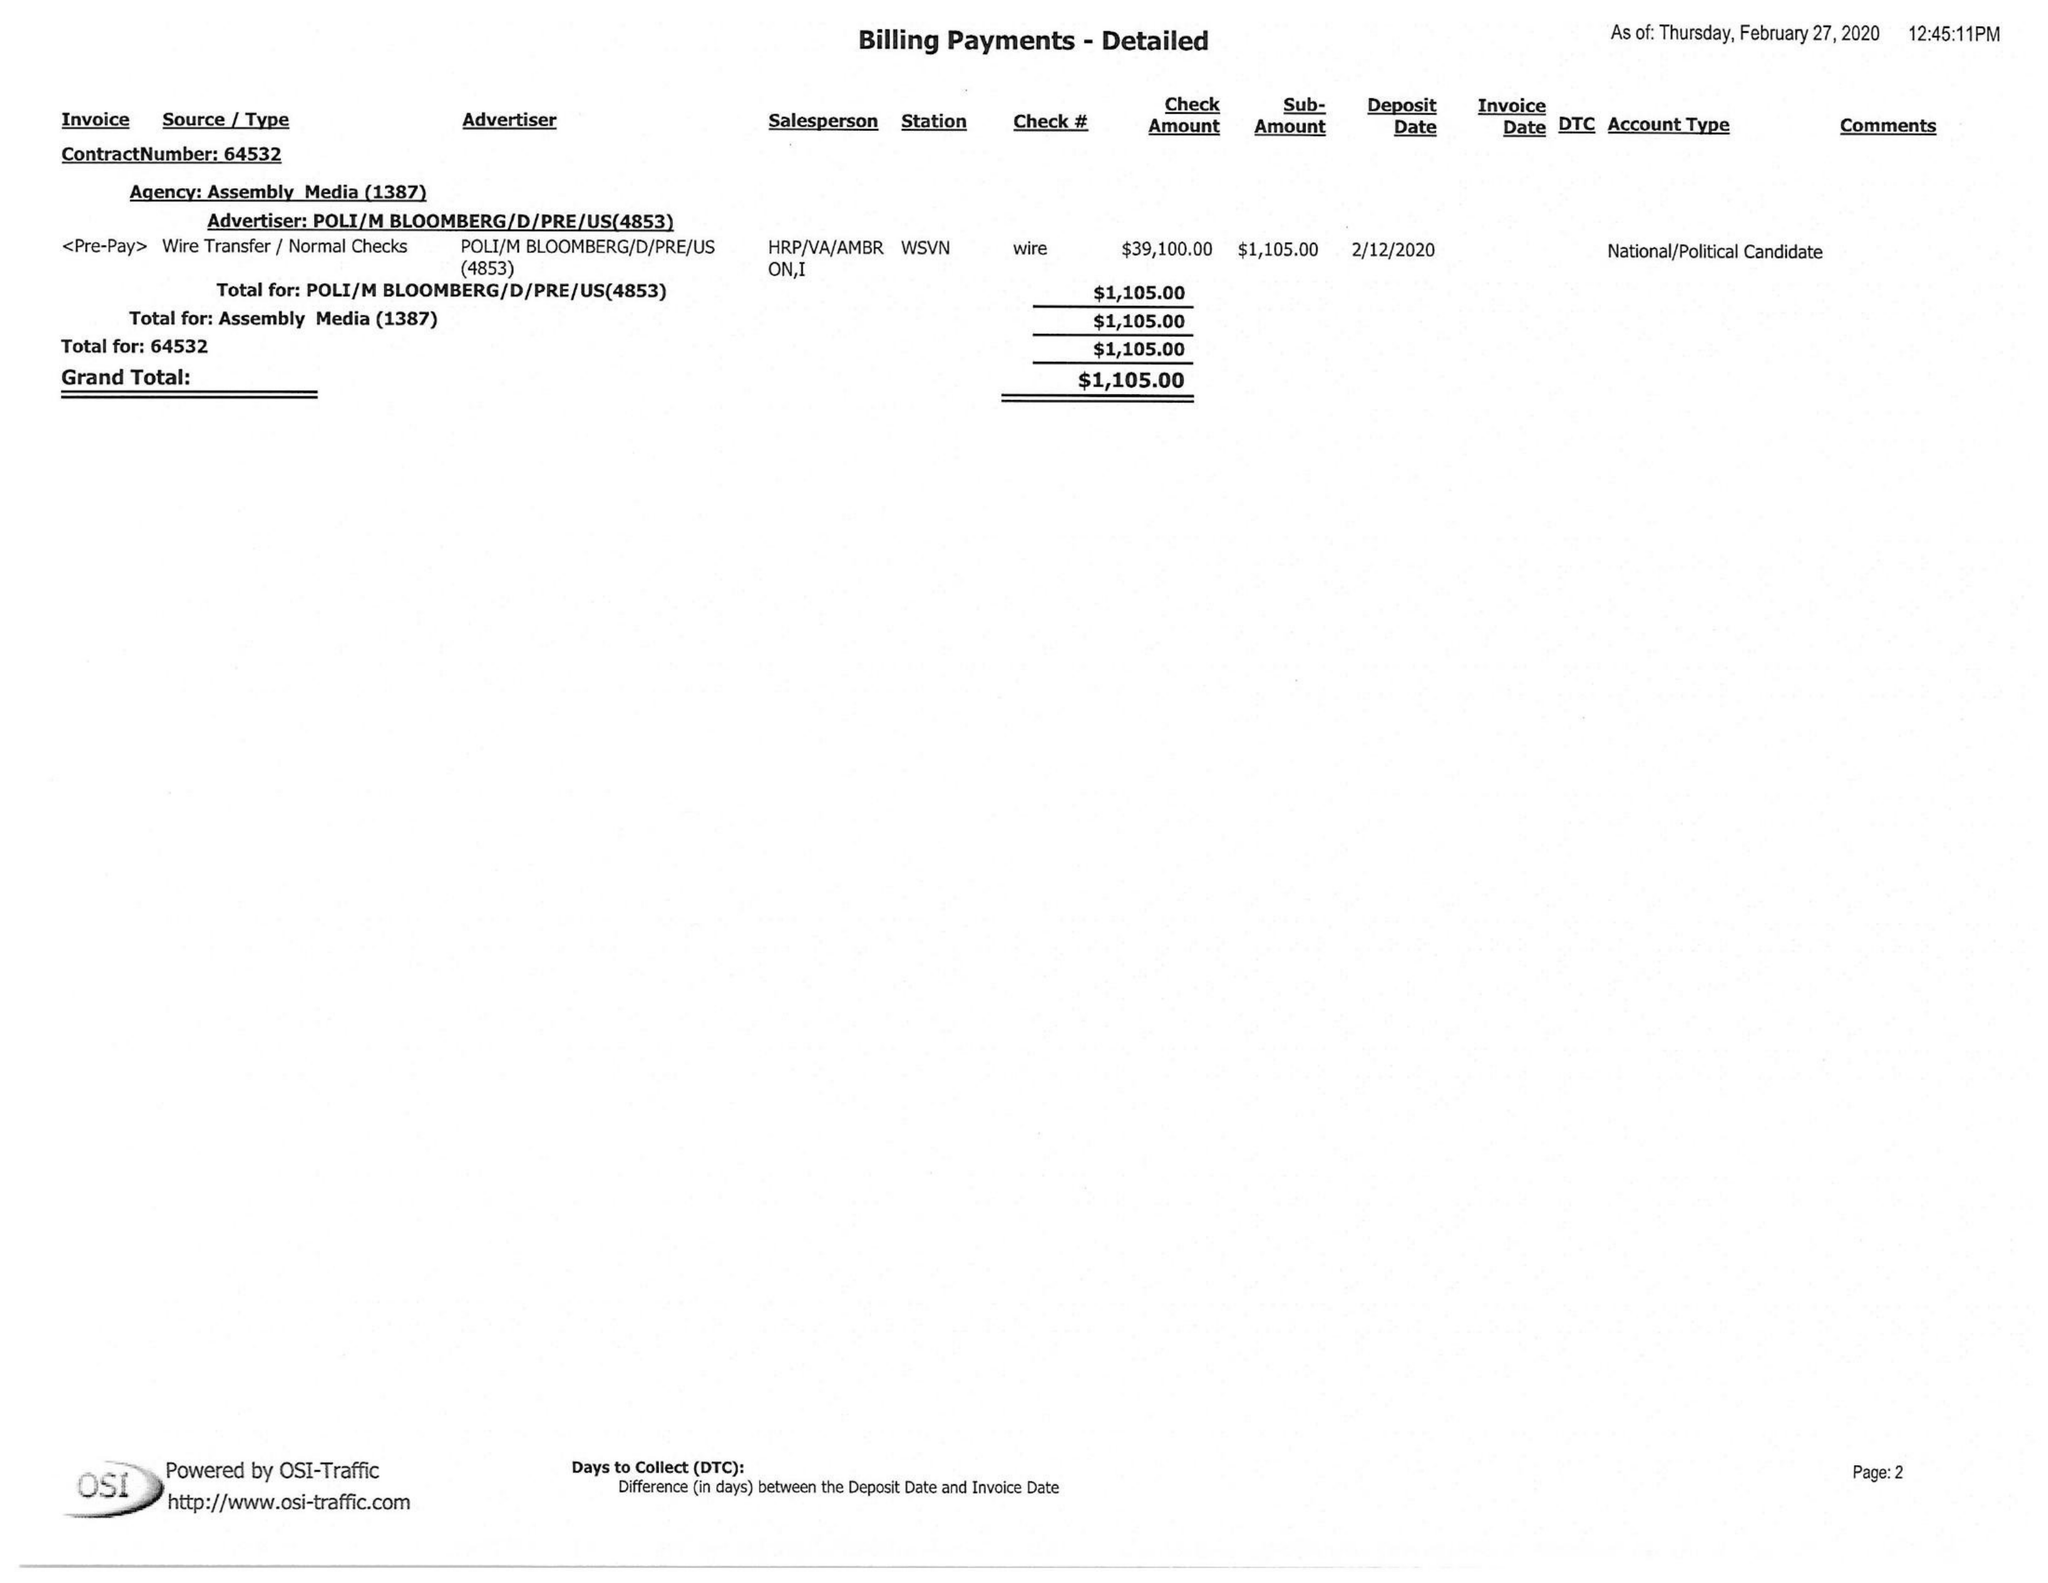What is the value for the flight_to?
Answer the question using a single word or phrase. None 